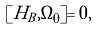<formula> <loc_0><loc_0><loc_500><loc_500>[ H _ { B } , \Omega _ { 0 } ] = 0 ,</formula> 